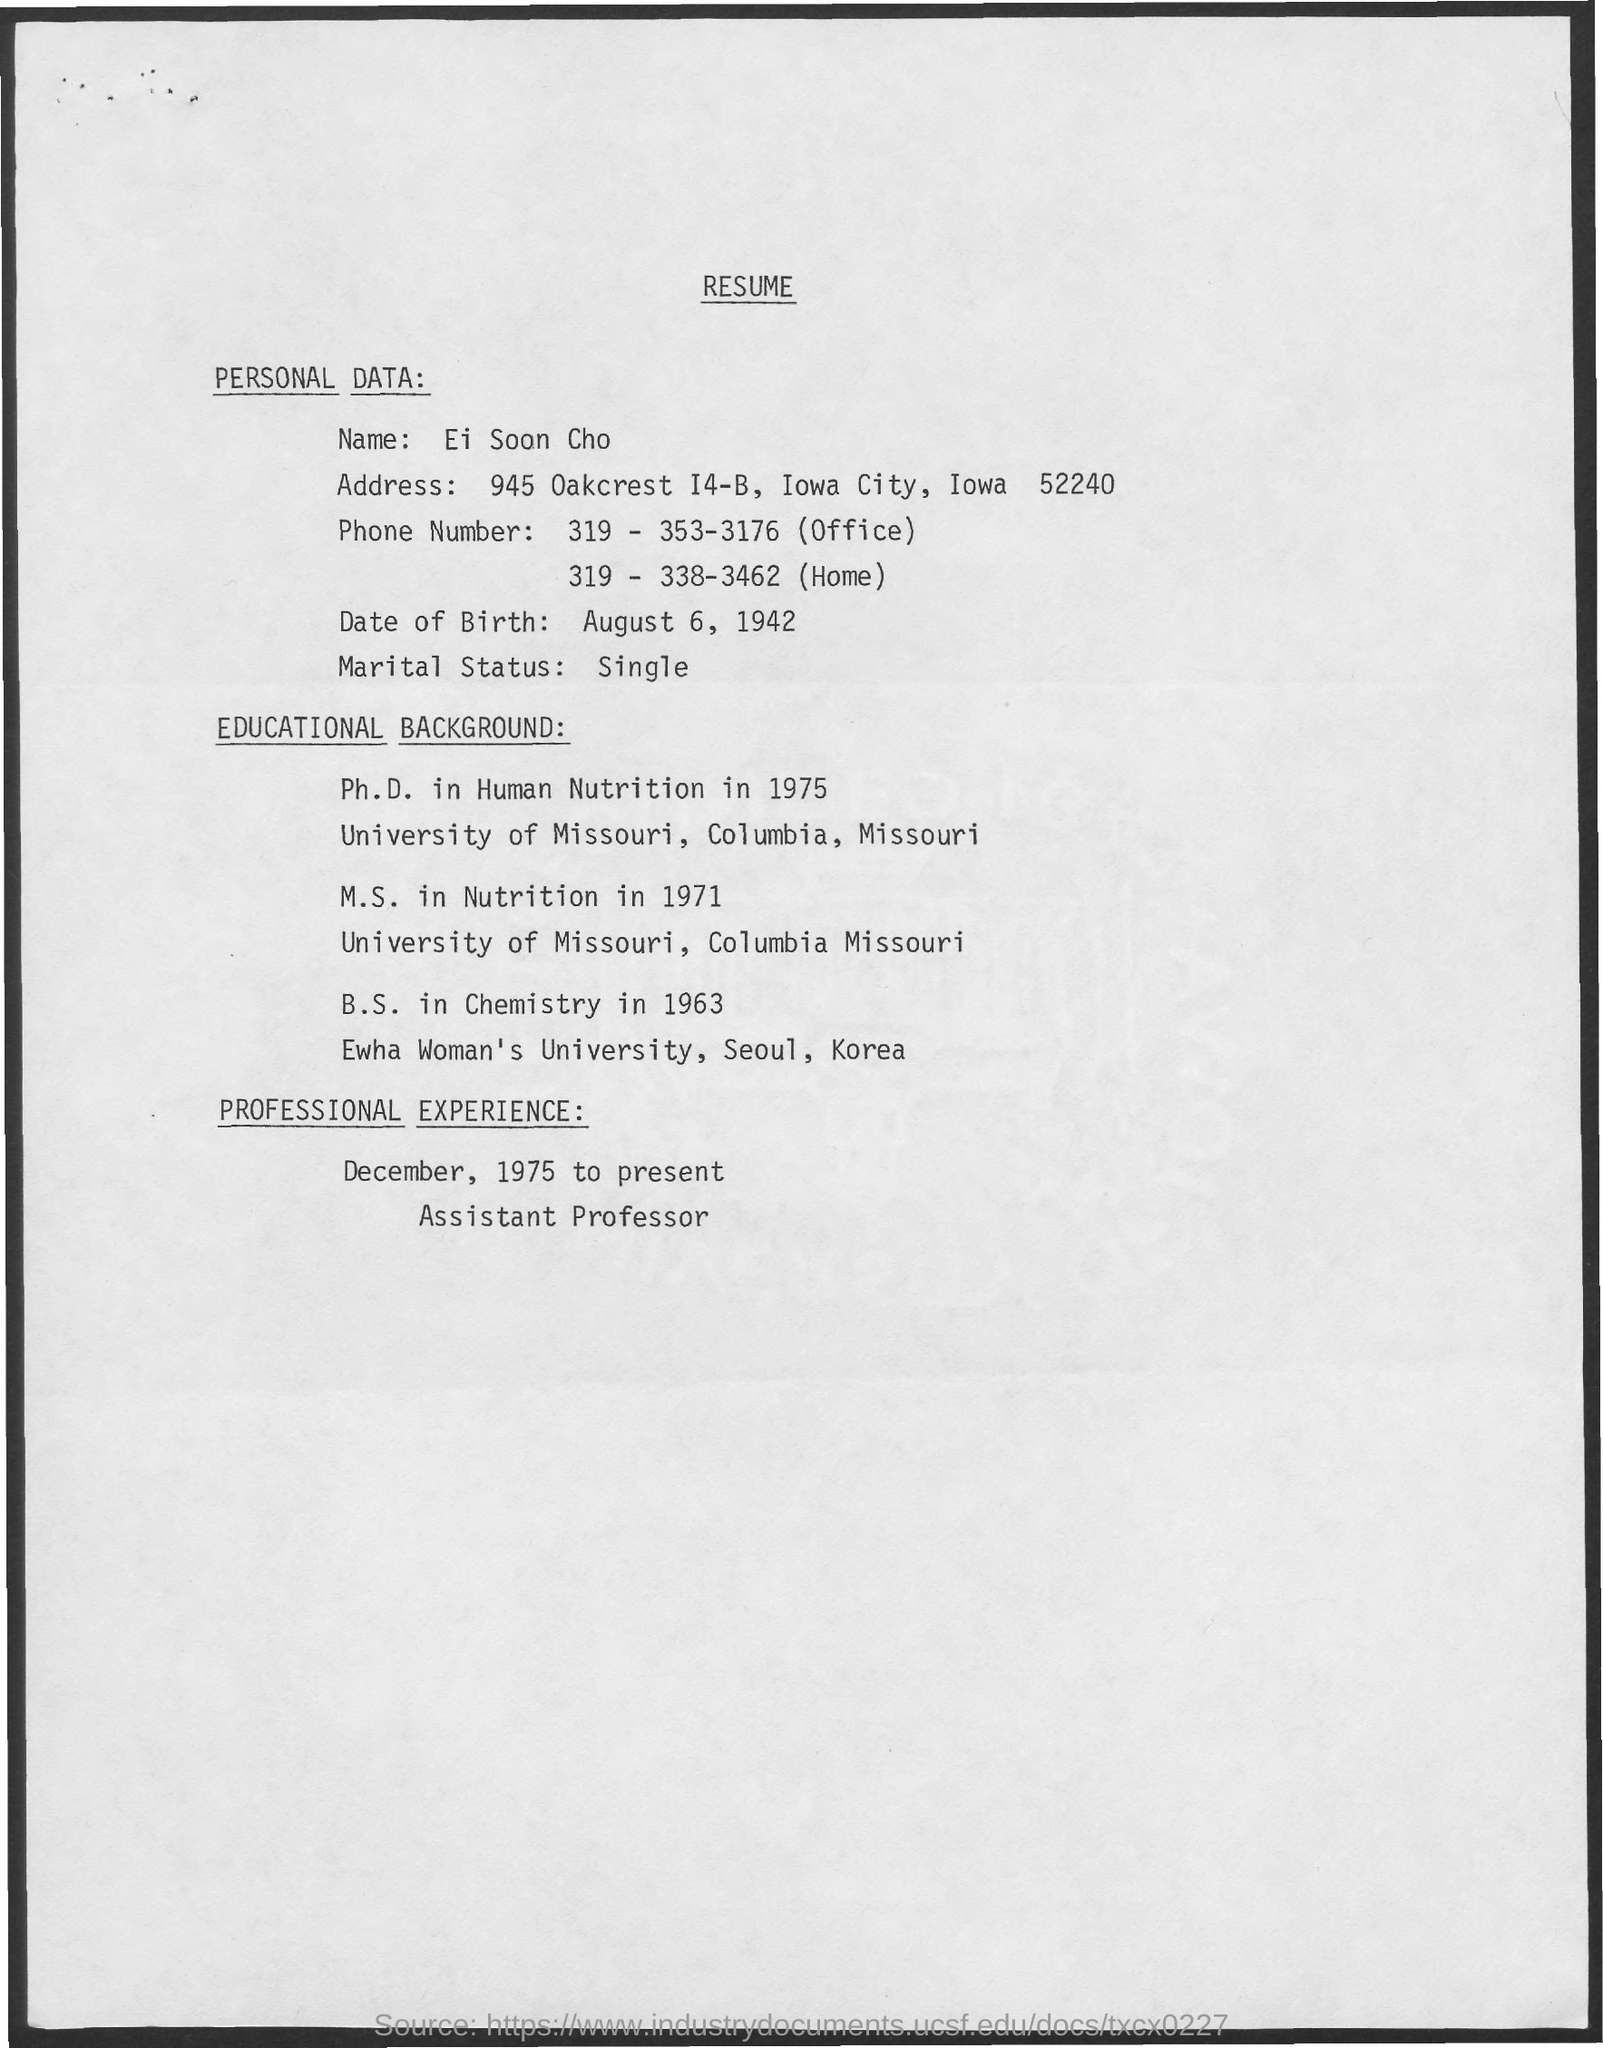What is the name of the person to whom this resume belongs to?
Make the answer very short. Ei Soon Cho. 